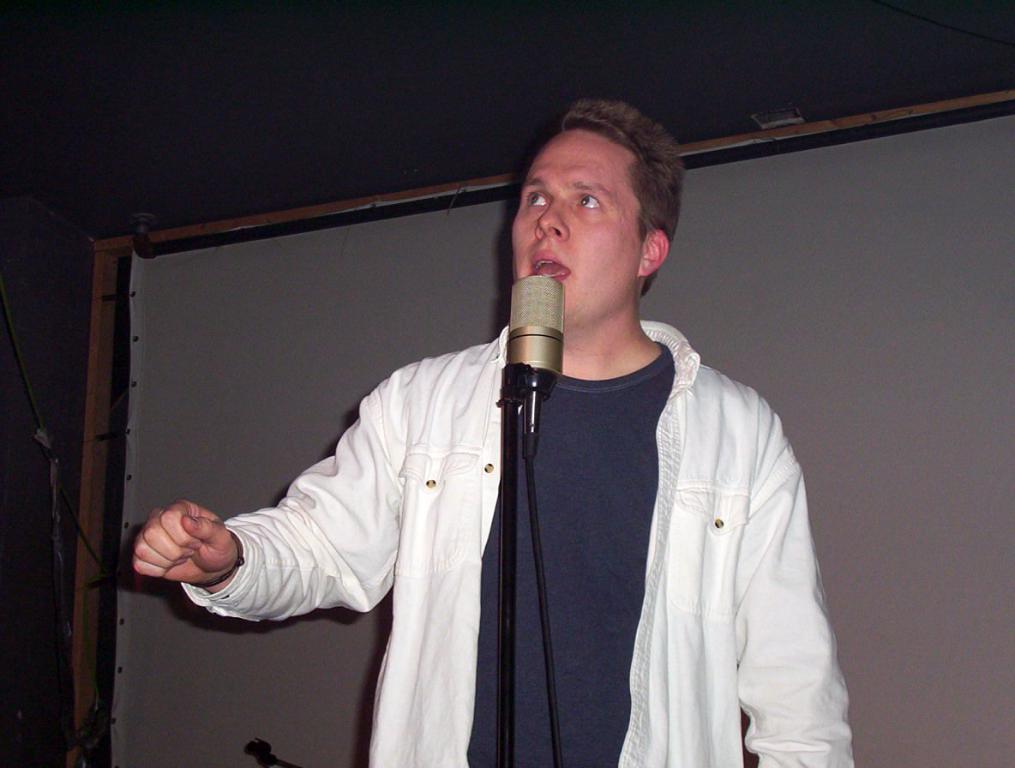Could you give a brief overview of what you see in this image? In this image I can see a person standing wearing white shirt, in front I can see a microphone. Background I can see a board in white color. 